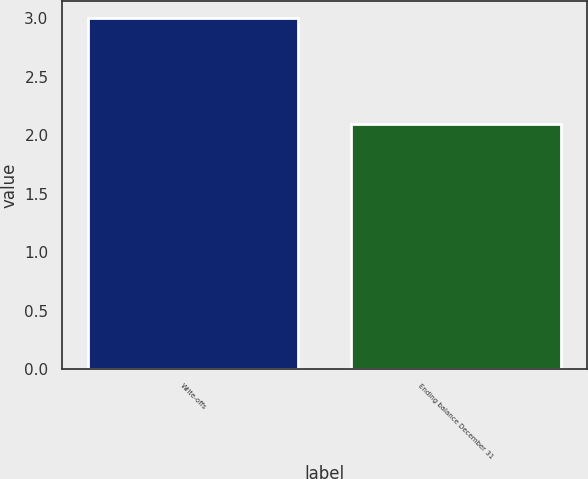Convert chart to OTSL. <chart><loc_0><loc_0><loc_500><loc_500><bar_chart><fcel>Write-offs<fcel>Ending balance December 31<nl><fcel>3<fcel>2.1<nl></chart> 